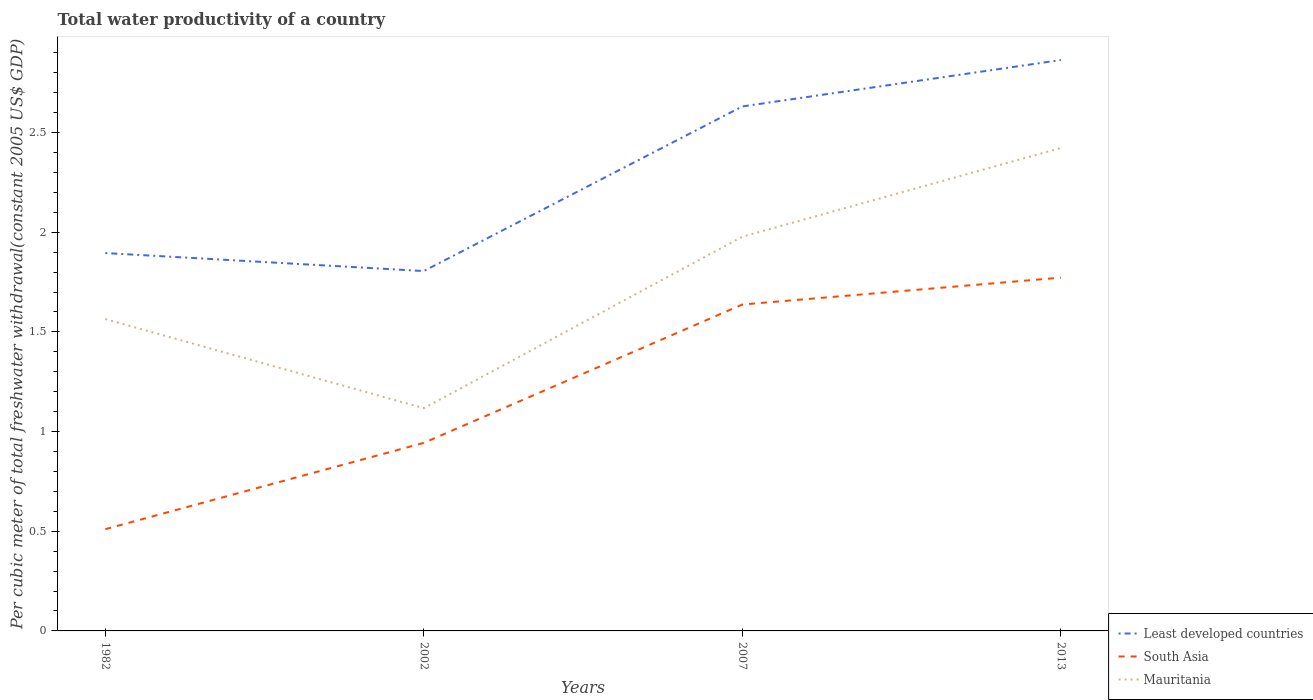How many different coloured lines are there?
Offer a very short reply. 3. Across all years, what is the maximum total water productivity in Least developed countries?
Your response must be concise. 1.81. In which year was the total water productivity in South Asia maximum?
Your answer should be compact. 1982. What is the total total water productivity in Mauritania in the graph?
Your response must be concise. 0.45. What is the difference between the highest and the second highest total water productivity in Least developed countries?
Ensure brevity in your answer.  1.06. How many lines are there?
Keep it short and to the point. 3. What is the difference between two consecutive major ticks on the Y-axis?
Your answer should be very brief. 0.5. Are the values on the major ticks of Y-axis written in scientific E-notation?
Give a very brief answer. No. Does the graph contain any zero values?
Give a very brief answer. No. Where does the legend appear in the graph?
Offer a very short reply. Bottom right. How are the legend labels stacked?
Keep it short and to the point. Vertical. What is the title of the graph?
Offer a terse response. Total water productivity of a country. Does "Monaco" appear as one of the legend labels in the graph?
Offer a very short reply. No. What is the label or title of the Y-axis?
Offer a very short reply. Per cubic meter of total freshwater withdrawal(constant 2005 US$ GDP). What is the Per cubic meter of total freshwater withdrawal(constant 2005 US$ GDP) in Least developed countries in 1982?
Give a very brief answer. 1.9. What is the Per cubic meter of total freshwater withdrawal(constant 2005 US$ GDP) of South Asia in 1982?
Your answer should be compact. 0.51. What is the Per cubic meter of total freshwater withdrawal(constant 2005 US$ GDP) of Mauritania in 1982?
Provide a succinct answer. 1.56. What is the Per cubic meter of total freshwater withdrawal(constant 2005 US$ GDP) of Least developed countries in 2002?
Provide a short and direct response. 1.81. What is the Per cubic meter of total freshwater withdrawal(constant 2005 US$ GDP) in South Asia in 2002?
Give a very brief answer. 0.94. What is the Per cubic meter of total freshwater withdrawal(constant 2005 US$ GDP) of Mauritania in 2002?
Offer a very short reply. 1.12. What is the Per cubic meter of total freshwater withdrawal(constant 2005 US$ GDP) in Least developed countries in 2007?
Provide a short and direct response. 2.63. What is the Per cubic meter of total freshwater withdrawal(constant 2005 US$ GDP) in South Asia in 2007?
Your answer should be very brief. 1.64. What is the Per cubic meter of total freshwater withdrawal(constant 2005 US$ GDP) in Mauritania in 2007?
Your response must be concise. 1.98. What is the Per cubic meter of total freshwater withdrawal(constant 2005 US$ GDP) in Least developed countries in 2013?
Provide a succinct answer. 2.86. What is the Per cubic meter of total freshwater withdrawal(constant 2005 US$ GDP) of South Asia in 2013?
Offer a terse response. 1.77. What is the Per cubic meter of total freshwater withdrawal(constant 2005 US$ GDP) of Mauritania in 2013?
Provide a short and direct response. 2.42. Across all years, what is the maximum Per cubic meter of total freshwater withdrawal(constant 2005 US$ GDP) of Least developed countries?
Make the answer very short. 2.86. Across all years, what is the maximum Per cubic meter of total freshwater withdrawal(constant 2005 US$ GDP) in South Asia?
Offer a very short reply. 1.77. Across all years, what is the maximum Per cubic meter of total freshwater withdrawal(constant 2005 US$ GDP) in Mauritania?
Offer a terse response. 2.42. Across all years, what is the minimum Per cubic meter of total freshwater withdrawal(constant 2005 US$ GDP) in Least developed countries?
Ensure brevity in your answer.  1.81. Across all years, what is the minimum Per cubic meter of total freshwater withdrawal(constant 2005 US$ GDP) of South Asia?
Ensure brevity in your answer.  0.51. Across all years, what is the minimum Per cubic meter of total freshwater withdrawal(constant 2005 US$ GDP) in Mauritania?
Provide a short and direct response. 1.12. What is the total Per cubic meter of total freshwater withdrawal(constant 2005 US$ GDP) of Least developed countries in the graph?
Your answer should be compact. 9.2. What is the total Per cubic meter of total freshwater withdrawal(constant 2005 US$ GDP) of South Asia in the graph?
Keep it short and to the point. 4.86. What is the total Per cubic meter of total freshwater withdrawal(constant 2005 US$ GDP) of Mauritania in the graph?
Offer a terse response. 7.08. What is the difference between the Per cubic meter of total freshwater withdrawal(constant 2005 US$ GDP) in Least developed countries in 1982 and that in 2002?
Your answer should be compact. 0.09. What is the difference between the Per cubic meter of total freshwater withdrawal(constant 2005 US$ GDP) in South Asia in 1982 and that in 2002?
Keep it short and to the point. -0.43. What is the difference between the Per cubic meter of total freshwater withdrawal(constant 2005 US$ GDP) in Mauritania in 1982 and that in 2002?
Provide a succinct answer. 0.45. What is the difference between the Per cubic meter of total freshwater withdrawal(constant 2005 US$ GDP) of Least developed countries in 1982 and that in 2007?
Give a very brief answer. -0.74. What is the difference between the Per cubic meter of total freshwater withdrawal(constant 2005 US$ GDP) of South Asia in 1982 and that in 2007?
Your answer should be very brief. -1.13. What is the difference between the Per cubic meter of total freshwater withdrawal(constant 2005 US$ GDP) of Mauritania in 1982 and that in 2007?
Your answer should be very brief. -0.41. What is the difference between the Per cubic meter of total freshwater withdrawal(constant 2005 US$ GDP) of Least developed countries in 1982 and that in 2013?
Offer a very short reply. -0.97. What is the difference between the Per cubic meter of total freshwater withdrawal(constant 2005 US$ GDP) of South Asia in 1982 and that in 2013?
Your response must be concise. -1.26. What is the difference between the Per cubic meter of total freshwater withdrawal(constant 2005 US$ GDP) of Mauritania in 1982 and that in 2013?
Offer a very short reply. -0.86. What is the difference between the Per cubic meter of total freshwater withdrawal(constant 2005 US$ GDP) in Least developed countries in 2002 and that in 2007?
Your response must be concise. -0.83. What is the difference between the Per cubic meter of total freshwater withdrawal(constant 2005 US$ GDP) in South Asia in 2002 and that in 2007?
Your response must be concise. -0.69. What is the difference between the Per cubic meter of total freshwater withdrawal(constant 2005 US$ GDP) in Mauritania in 2002 and that in 2007?
Your answer should be very brief. -0.86. What is the difference between the Per cubic meter of total freshwater withdrawal(constant 2005 US$ GDP) in Least developed countries in 2002 and that in 2013?
Keep it short and to the point. -1.06. What is the difference between the Per cubic meter of total freshwater withdrawal(constant 2005 US$ GDP) of South Asia in 2002 and that in 2013?
Your answer should be very brief. -0.83. What is the difference between the Per cubic meter of total freshwater withdrawal(constant 2005 US$ GDP) in Mauritania in 2002 and that in 2013?
Your response must be concise. -1.31. What is the difference between the Per cubic meter of total freshwater withdrawal(constant 2005 US$ GDP) of Least developed countries in 2007 and that in 2013?
Your answer should be very brief. -0.23. What is the difference between the Per cubic meter of total freshwater withdrawal(constant 2005 US$ GDP) of South Asia in 2007 and that in 2013?
Provide a succinct answer. -0.13. What is the difference between the Per cubic meter of total freshwater withdrawal(constant 2005 US$ GDP) in Mauritania in 2007 and that in 2013?
Make the answer very short. -0.45. What is the difference between the Per cubic meter of total freshwater withdrawal(constant 2005 US$ GDP) in Least developed countries in 1982 and the Per cubic meter of total freshwater withdrawal(constant 2005 US$ GDP) in Mauritania in 2002?
Provide a succinct answer. 0.78. What is the difference between the Per cubic meter of total freshwater withdrawal(constant 2005 US$ GDP) of South Asia in 1982 and the Per cubic meter of total freshwater withdrawal(constant 2005 US$ GDP) of Mauritania in 2002?
Keep it short and to the point. -0.61. What is the difference between the Per cubic meter of total freshwater withdrawal(constant 2005 US$ GDP) in Least developed countries in 1982 and the Per cubic meter of total freshwater withdrawal(constant 2005 US$ GDP) in South Asia in 2007?
Offer a very short reply. 0.26. What is the difference between the Per cubic meter of total freshwater withdrawal(constant 2005 US$ GDP) in Least developed countries in 1982 and the Per cubic meter of total freshwater withdrawal(constant 2005 US$ GDP) in Mauritania in 2007?
Your answer should be compact. -0.08. What is the difference between the Per cubic meter of total freshwater withdrawal(constant 2005 US$ GDP) of South Asia in 1982 and the Per cubic meter of total freshwater withdrawal(constant 2005 US$ GDP) of Mauritania in 2007?
Make the answer very short. -1.47. What is the difference between the Per cubic meter of total freshwater withdrawal(constant 2005 US$ GDP) in Least developed countries in 1982 and the Per cubic meter of total freshwater withdrawal(constant 2005 US$ GDP) in South Asia in 2013?
Provide a succinct answer. 0.12. What is the difference between the Per cubic meter of total freshwater withdrawal(constant 2005 US$ GDP) in Least developed countries in 1982 and the Per cubic meter of total freshwater withdrawal(constant 2005 US$ GDP) in Mauritania in 2013?
Offer a very short reply. -0.53. What is the difference between the Per cubic meter of total freshwater withdrawal(constant 2005 US$ GDP) in South Asia in 1982 and the Per cubic meter of total freshwater withdrawal(constant 2005 US$ GDP) in Mauritania in 2013?
Ensure brevity in your answer.  -1.91. What is the difference between the Per cubic meter of total freshwater withdrawal(constant 2005 US$ GDP) of Least developed countries in 2002 and the Per cubic meter of total freshwater withdrawal(constant 2005 US$ GDP) of South Asia in 2007?
Make the answer very short. 0.17. What is the difference between the Per cubic meter of total freshwater withdrawal(constant 2005 US$ GDP) in Least developed countries in 2002 and the Per cubic meter of total freshwater withdrawal(constant 2005 US$ GDP) in Mauritania in 2007?
Offer a terse response. -0.17. What is the difference between the Per cubic meter of total freshwater withdrawal(constant 2005 US$ GDP) in South Asia in 2002 and the Per cubic meter of total freshwater withdrawal(constant 2005 US$ GDP) in Mauritania in 2007?
Keep it short and to the point. -1.03. What is the difference between the Per cubic meter of total freshwater withdrawal(constant 2005 US$ GDP) of Least developed countries in 2002 and the Per cubic meter of total freshwater withdrawal(constant 2005 US$ GDP) of South Asia in 2013?
Your answer should be very brief. 0.03. What is the difference between the Per cubic meter of total freshwater withdrawal(constant 2005 US$ GDP) of Least developed countries in 2002 and the Per cubic meter of total freshwater withdrawal(constant 2005 US$ GDP) of Mauritania in 2013?
Make the answer very short. -0.62. What is the difference between the Per cubic meter of total freshwater withdrawal(constant 2005 US$ GDP) of South Asia in 2002 and the Per cubic meter of total freshwater withdrawal(constant 2005 US$ GDP) of Mauritania in 2013?
Offer a terse response. -1.48. What is the difference between the Per cubic meter of total freshwater withdrawal(constant 2005 US$ GDP) of Least developed countries in 2007 and the Per cubic meter of total freshwater withdrawal(constant 2005 US$ GDP) of South Asia in 2013?
Provide a short and direct response. 0.86. What is the difference between the Per cubic meter of total freshwater withdrawal(constant 2005 US$ GDP) of Least developed countries in 2007 and the Per cubic meter of total freshwater withdrawal(constant 2005 US$ GDP) of Mauritania in 2013?
Your answer should be very brief. 0.21. What is the difference between the Per cubic meter of total freshwater withdrawal(constant 2005 US$ GDP) in South Asia in 2007 and the Per cubic meter of total freshwater withdrawal(constant 2005 US$ GDP) in Mauritania in 2013?
Keep it short and to the point. -0.79. What is the average Per cubic meter of total freshwater withdrawal(constant 2005 US$ GDP) in Least developed countries per year?
Your response must be concise. 2.3. What is the average Per cubic meter of total freshwater withdrawal(constant 2005 US$ GDP) in South Asia per year?
Your answer should be very brief. 1.22. What is the average Per cubic meter of total freshwater withdrawal(constant 2005 US$ GDP) of Mauritania per year?
Make the answer very short. 1.77. In the year 1982, what is the difference between the Per cubic meter of total freshwater withdrawal(constant 2005 US$ GDP) in Least developed countries and Per cubic meter of total freshwater withdrawal(constant 2005 US$ GDP) in South Asia?
Offer a terse response. 1.39. In the year 1982, what is the difference between the Per cubic meter of total freshwater withdrawal(constant 2005 US$ GDP) of Least developed countries and Per cubic meter of total freshwater withdrawal(constant 2005 US$ GDP) of Mauritania?
Your answer should be very brief. 0.33. In the year 1982, what is the difference between the Per cubic meter of total freshwater withdrawal(constant 2005 US$ GDP) of South Asia and Per cubic meter of total freshwater withdrawal(constant 2005 US$ GDP) of Mauritania?
Give a very brief answer. -1.05. In the year 2002, what is the difference between the Per cubic meter of total freshwater withdrawal(constant 2005 US$ GDP) in Least developed countries and Per cubic meter of total freshwater withdrawal(constant 2005 US$ GDP) in South Asia?
Give a very brief answer. 0.86. In the year 2002, what is the difference between the Per cubic meter of total freshwater withdrawal(constant 2005 US$ GDP) of Least developed countries and Per cubic meter of total freshwater withdrawal(constant 2005 US$ GDP) of Mauritania?
Your answer should be very brief. 0.69. In the year 2002, what is the difference between the Per cubic meter of total freshwater withdrawal(constant 2005 US$ GDP) in South Asia and Per cubic meter of total freshwater withdrawal(constant 2005 US$ GDP) in Mauritania?
Provide a short and direct response. -0.17. In the year 2007, what is the difference between the Per cubic meter of total freshwater withdrawal(constant 2005 US$ GDP) of Least developed countries and Per cubic meter of total freshwater withdrawal(constant 2005 US$ GDP) of South Asia?
Your answer should be very brief. 0.99. In the year 2007, what is the difference between the Per cubic meter of total freshwater withdrawal(constant 2005 US$ GDP) in Least developed countries and Per cubic meter of total freshwater withdrawal(constant 2005 US$ GDP) in Mauritania?
Keep it short and to the point. 0.65. In the year 2007, what is the difference between the Per cubic meter of total freshwater withdrawal(constant 2005 US$ GDP) in South Asia and Per cubic meter of total freshwater withdrawal(constant 2005 US$ GDP) in Mauritania?
Provide a succinct answer. -0.34. In the year 2013, what is the difference between the Per cubic meter of total freshwater withdrawal(constant 2005 US$ GDP) in Least developed countries and Per cubic meter of total freshwater withdrawal(constant 2005 US$ GDP) in South Asia?
Offer a very short reply. 1.09. In the year 2013, what is the difference between the Per cubic meter of total freshwater withdrawal(constant 2005 US$ GDP) in Least developed countries and Per cubic meter of total freshwater withdrawal(constant 2005 US$ GDP) in Mauritania?
Your answer should be very brief. 0.44. In the year 2013, what is the difference between the Per cubic meter of total freshwater withdrawal(constant 2005 US$ GDP) in South Asia and Per cubic meter of total freshwater withdrawal(constant 2005 US$ GDP) in Mauritania?
Provide a short and direct response. -0.65. What is the ratio of the Per cubic meter of total freshwater withdrawal(constant 2005 US$ GDP) of Least developed countries in 1982 to that in 2002?
Give a very brief answer. 1.05. What is the ratio of the Per cubic meter of total freshwater withdrawal(constant 2005 US$ GDP) in South Asia in 1982 to that in 2002?
Your response must be concise. 0.54. What is the ratio of the Per cubic meter of total freshwater withdrawal(constant 2005 US$ GDP) of Mauritania in 1982 to that in 2002?
Your response must be concise. 1.4. What is the ratio of the Per cubic meter of total freshwater withdrawal(constant 2005 US$ GDP) in Least developed countries in 1982 to that in 2007?
Provide a succinct answer. 0.72. What is the ratio of the Per cubic meter of total freshwater withdrawal(constant 2005 US$ GDP) in South Asia in 1982 to that in 2007?
Provide a short and direct response. 0.31. What is the ratio of the Per cubic meter of total freshwater withdrawal(constant 2005 US$ GDP) of Mauritania in 1982 to that in 2007?
Make the answer very short. 0.79. What is the ratio of the Per cubic meter of total freshwater withdrawal(constant 2005 US$ GDP) of Least developed countries in 1982 to that in 2013?
Offer a very short reply. 0.66. What is the ratio of the Per cubic meter of total freshwater withdrawal(constant 2005 US$ GDP) of South Asia in 1982 to that in 2013?
Your response must be concise. 0.29. What is the ratio of the Per cubic meter of total freshwater withdrawal(constant 2005 US$ GDP) in Mauritania in 1982 to that in 2013?
Provide a short and direct response. 0.65. What is the ratio of the Per cubic meter of total freshwater withdrawal(constant 2005 US$ GDP) in Least developed countries in 2002 to that in 2007?
Your answer should be compact. 0.69. What is the ratio of the Per cubic meter of total freshwater withdrawal(constant 2005 US$ GDP) in South Asia in 2002 to that in 2007?
Your answer should be very brief. 0.58. What is the ratio of the Per cubic meter of total freshwater withdrawal(constant 2005 US$ GDP) of Mauritania in 2002 to that in 2007?
Your answer should be very brief. 0.56. What is the ratio of the Per cubic meter of total freshwater withdrawal(constant 2005 US$ GDP) in Least developed countries in 2002 to that in 2013?
Keep it short and to the point. 0.63. What is the ratio of the Per cubic meter of total freshwater withdrawal(constant 2005 US$ GDP) in South Asia in 2002 to that in 2013?
Make the answer very short. 0.53. What is the ratio of the Per cubic meter of total freshwater withdrawal(constant 2005 US$ GDP) in Mauritania in 2002 to that in 2013?
Give a very brief answer. 0.46. What is the ratio of the Per cubic meter of total freshwater withdrawal(constant 2005 US$ GDP) of Least developed countries in 2007 to that in 2013?
Provide a short and direct response. 0.92. What is the ratio of the Per cubic meter of total freshwater withdrawal(constant 2005 US$ GDP) of South Asia in 2007 to that in 2013?
Your answer should be very brief. 0.92. What is the ratio of the Per cubic meter of total freshwater withdrawal(constant 2005 US$ GDP) of Mauritania in 2007 to that in 2013?
Your answer should be compact. 0.82. What is the difference between the highest and the second highest Per cubic meter of total freshwater withdrawal(constant 2005 US$ GDP) of Least developed countries?
Offer a very short reply. 0.23. What is the difference between the highest and the second highest Per cubic meter of total freshwater withdrawal(constant 2005 US$ GDP) of South Asia?
Offer a very short reply. 0.13. What is the difference between the highest and the second highest Per cubic meter of total freshwater withdrawal(constant 2005 US$ GDP) of Mauritania?
Offer a very short reply. 0.45. What is the difference between the highest and the lowest Per cubic meter of total freshwater withdrawal(constant 2005 US$ GDP) of Least developed countries?
Your response must be concise. 1.06. What is the difference between the highest and the lowest Per cubic meter of total freshwater withdrawal(constant 2005 US$ GDP) of South Asia?
Provide a succinct answer. 1.26. What is the difference between the highest and the lowest Per cubic meter of total freshwater withdrawal(constant 2005 US$ GDP) of Mauritania?
Your response must be concise. 1.31. 